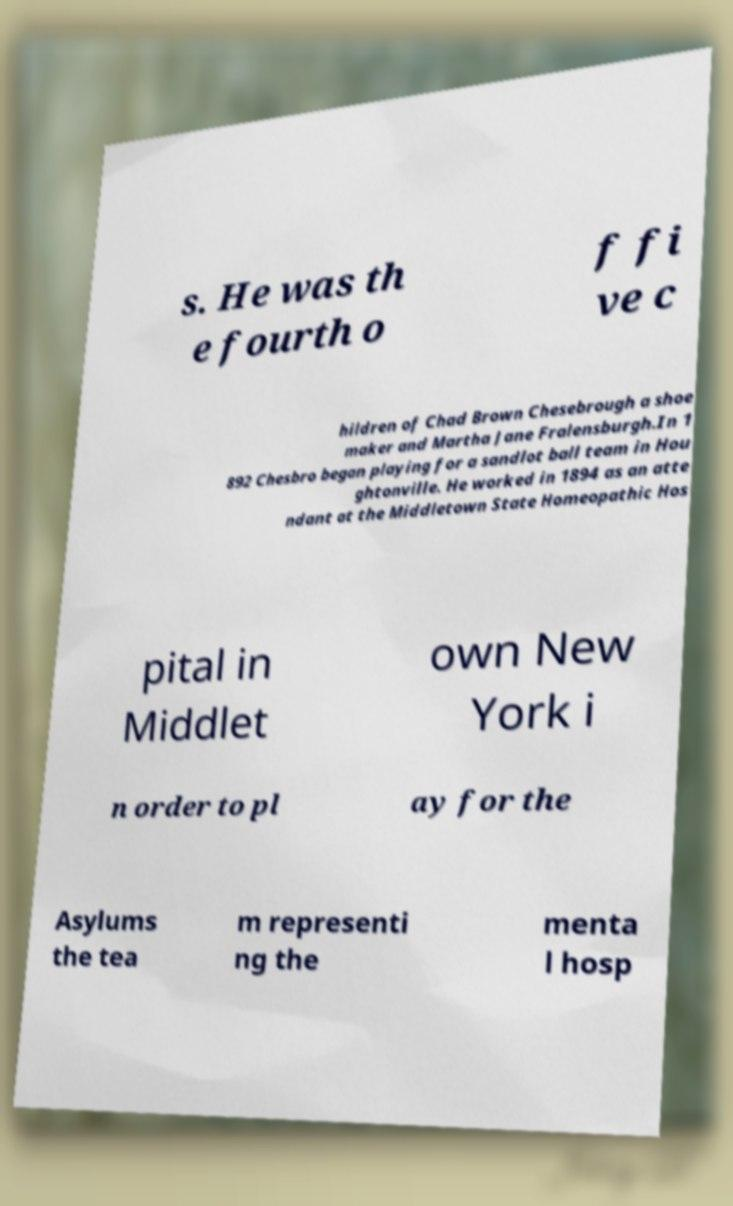Could you assist in decoding the text presented in this image and type it out clearly? s. He was th e fourth o f fi ve c hildren of Chad Brown Chesebrough a shoe maker and Martha Jane Fralensburgh.In 1 892 Chesbro began playing for a sandlot ball team in Hou ghtonville. He worked in 1894 as an atte ndant at the Middletown State Homeopathic Hos pital in Middlet own New York i n order to pl ay for the Asylums the tea m representi ng the menta l hosp 